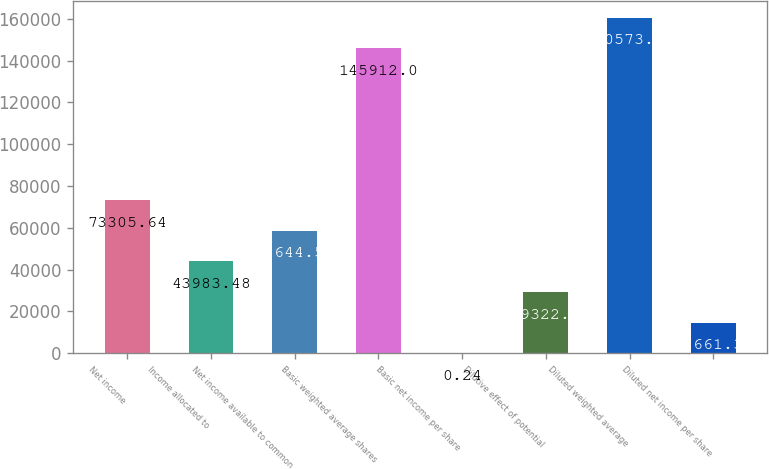Convert chart to OTSL. <chart><loc_0><loc_0><loc_500><loc_500><bar_chart><fcel>Net income<fcel>Income allocated to<fcel>Net income available to common<fcel>Basic weighted average shares<fcel>Basic net income per share<fcel>Dilutive effect of potential<fcel>Diluted weighted average<fcel>Diluted net income per share<nl><fcel>73305.6<fcel>43983.5<fcel>58644.6<fcel>145912<fcel>0.24<fcel>29322.4<fcel>160573<fcel>14661.3<nl></chart> 